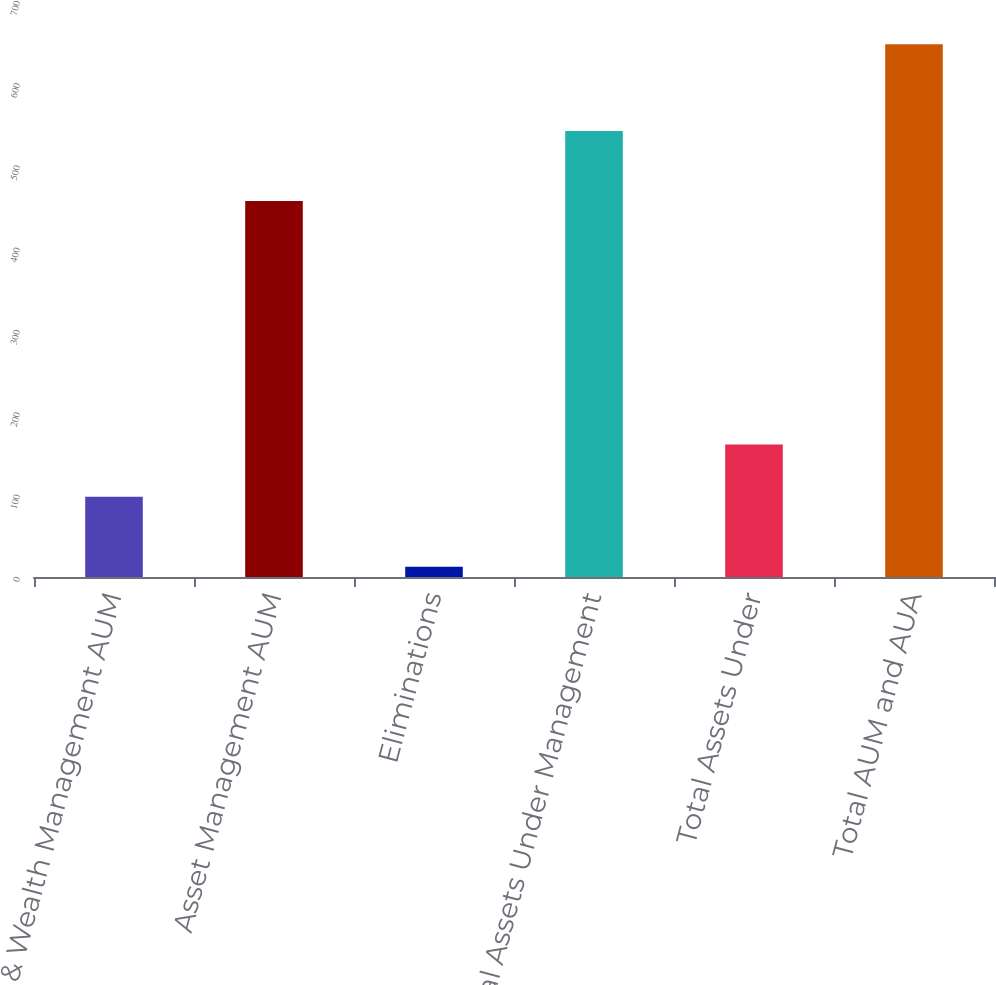Convert chart. <chart><loc_0><loc_0><loc_500><loc_500><bar_chart><fcel>Advice & Wealth Management AUM<fcel>Asset Management AUM<fcel>Eliminations<fcel>Total Assets Under Management<fcel>Total Assets Under<fcel>Total AUM and AUA<nl><fcel>97.5<fcel>456.8<fcel>12.4<fcel>541.9<fcel>161.01<fcel>647.5<nl></chart> 